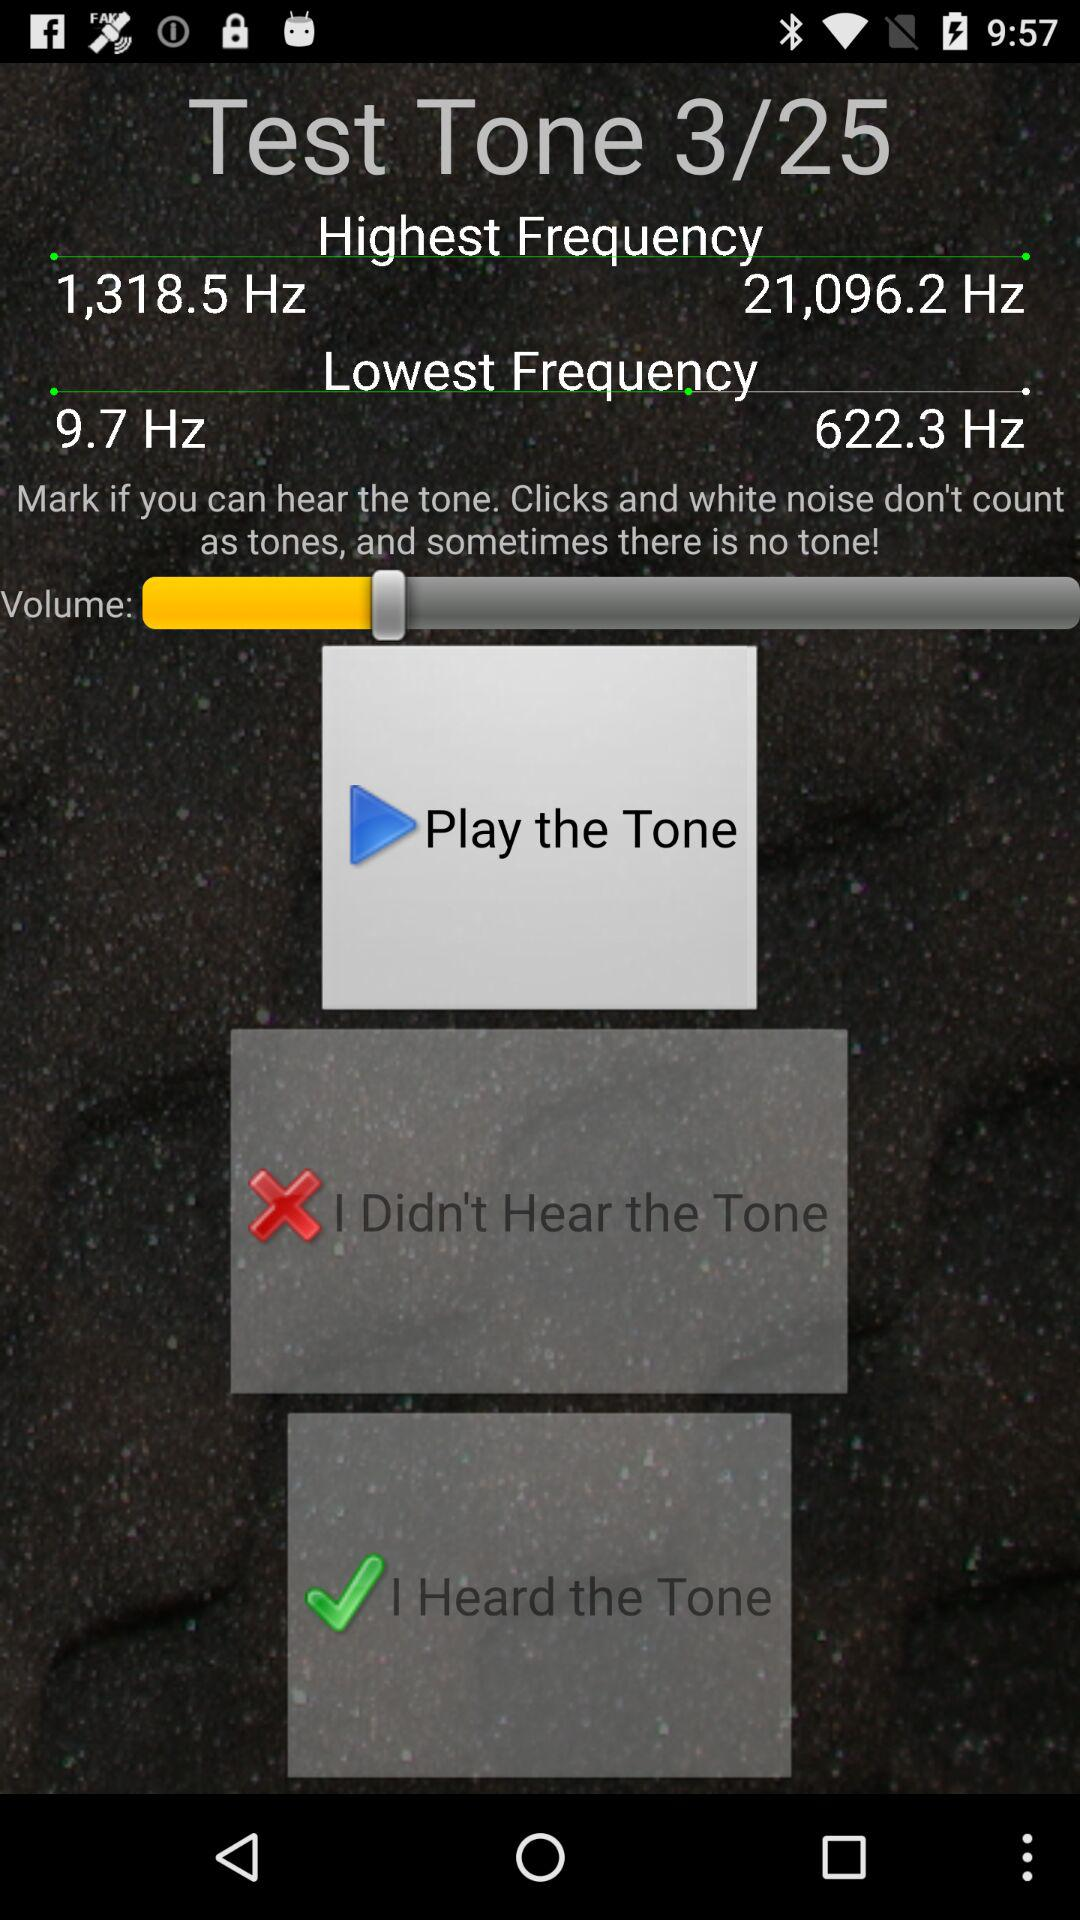At which "Test Tone" are we currently? You are currently at "Test Tone" 3. 